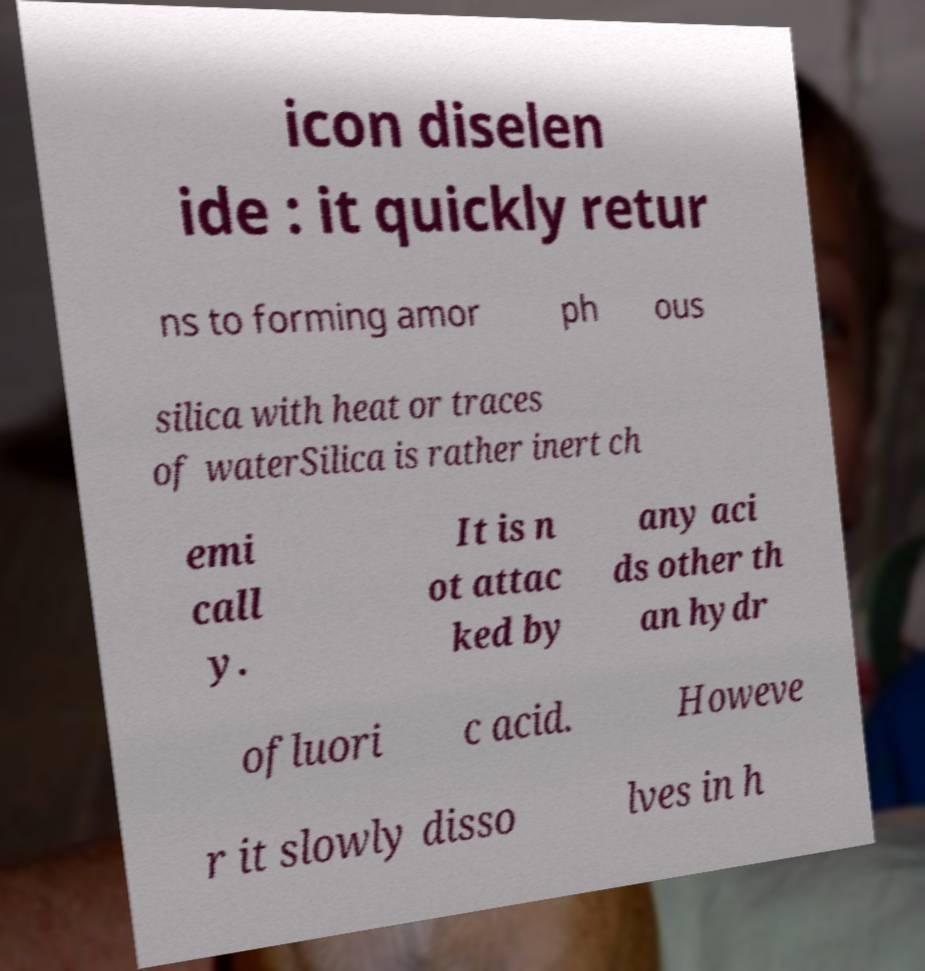I need the written content from this picture converted into text. Can you do that? icon diselen ide : it quickly retur ns to forming amor ph ous silica with heat or traces of waterSilica is rather inert ch emi call y. It is n ot attac ked by any aci ds other th an hydr ofluori c acid. Howeve r it slowly disso lves in h 